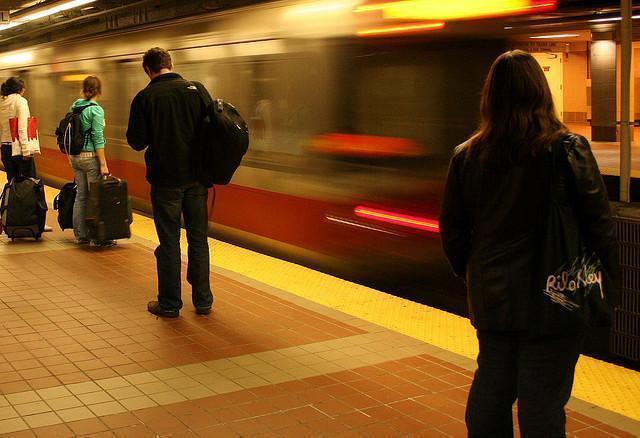What do the people do when the fast moving thing stops?
Select the accurate answer and provide explanation: 'Answer: answer
Rationale: rationale.'
Options: Exercise, cook, swim, board it. Answer: board it.
Rationale: The fast-moving thing is a train that the people are waiting for it to come to a stop so they can get on. 